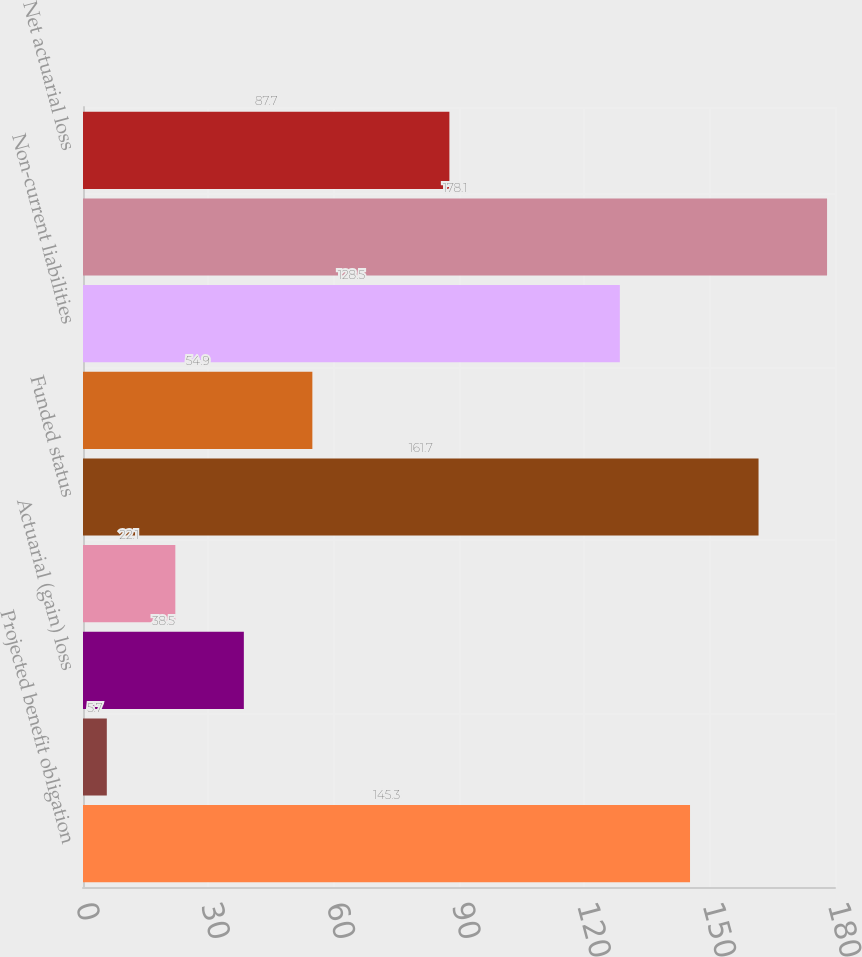Convert chart. <chart><loc_0><loc_0><loc_500><loc_500><bar_chart><fcel>Projected benefit obligation<fcel>Interest cost<fcel>Actuarial (gain) loss<fcel>Benefits paid<fcel>Funded status<fcel>Current liabilities<fcel>Non-current liabilities<fcel>Net amount<fcel>Net actuarial loss<nl><fcel>145.3<fcel>5.7<fcel>38.5<fcel>22.1<fcel>161.7<fcel>54.9<fcel>128.5<fcel>178.1<fcel>87.7<nl></chart> 